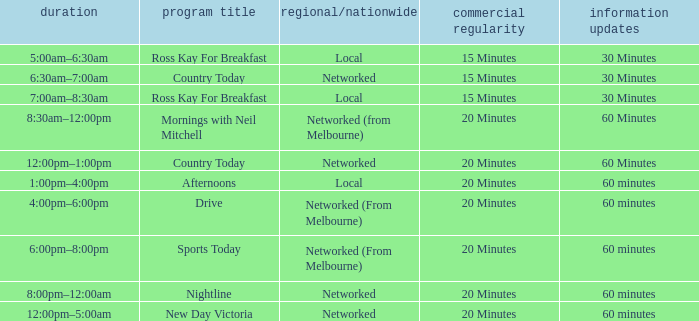What Time has Ad Freq of 15 minutes, and a Show Name of country today? 6:30am–7:00am. 